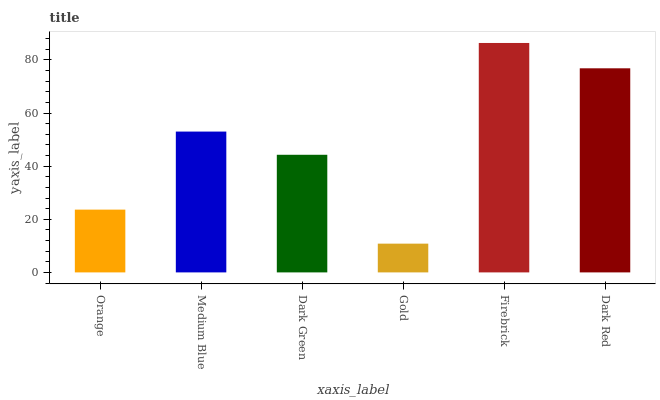Is Gold the minimum?
Answer yes or no. Yes. Is Firebrick the maximum?
Answer yes or no. Yes. Is Medium Blue the minimum?
Answer yes or no. No. Is Medium Blue the maximum?
Answer yes or no. No. Is Medium Blue greater than Orange?
Answer yes or no. Yes. Is Orange less than Medium Blue?
Answer yes or no. Yes. Is Orange greater than Medium Blue?
Answer yes or no. No. Is Medium Blue less than Orange?
Answer yes or no. No. Is Medium Blue the high median?
Answer yes or no. Yes. Is Dark Green the low median?
Answer yes or no. Yes. Is Gold the high median?
Answer yes or no. No. Is Gold the low median?
Answer yes or no. No. 